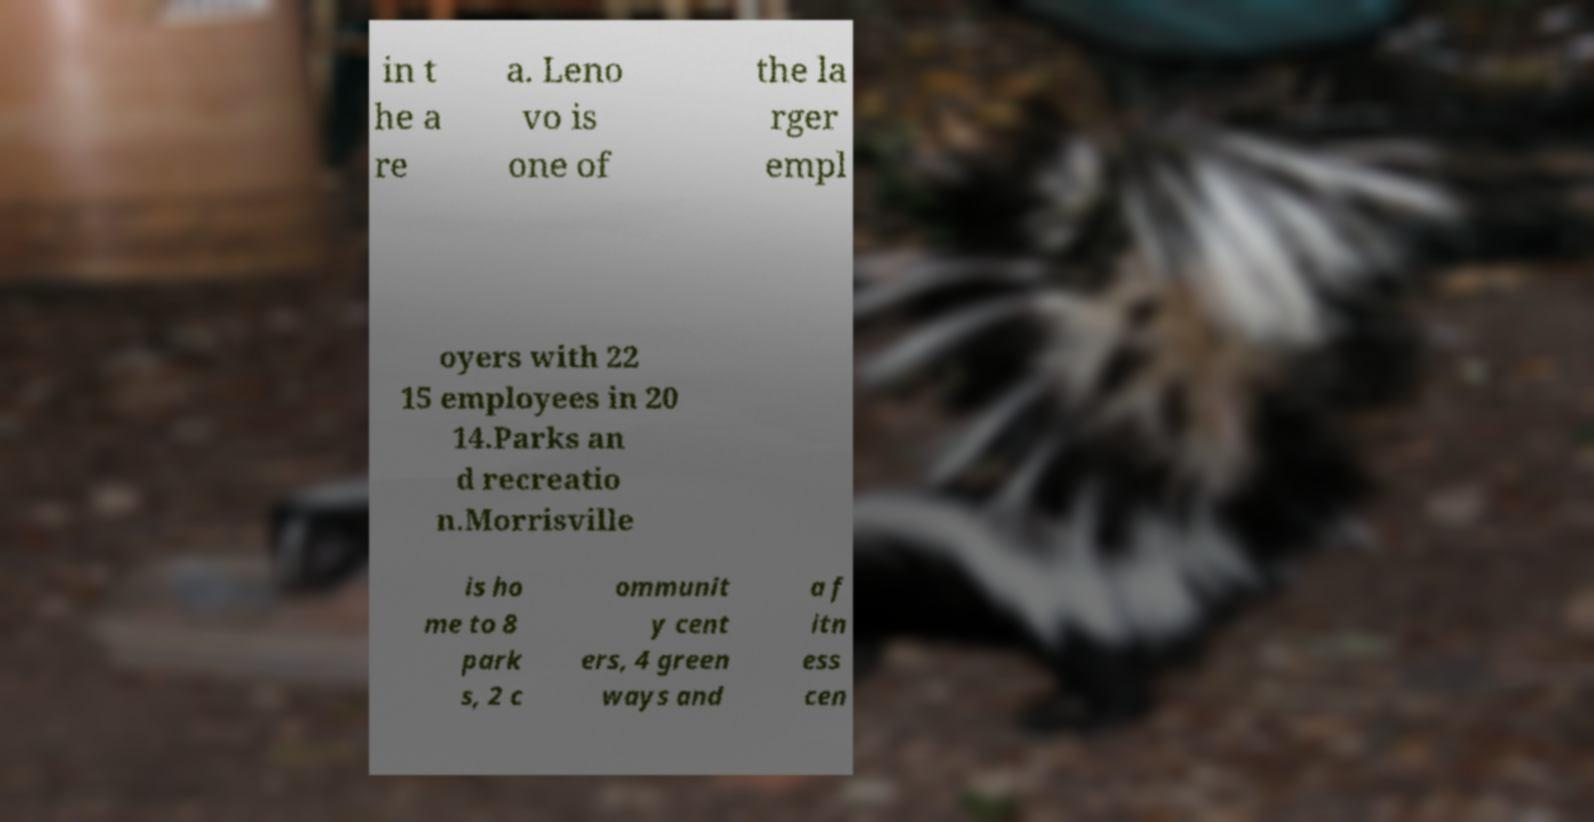I need the written content from this picture converted into text. Can you do that? in t he a re a. Leno vo is one of the la rger empl oyers with 22 15 employees in 20 14.Parks an d recreatio n.Morrisville is ho me to 8 park s, 2 c ommunit y cent ers, 4 green ways and a f itn ess cen 